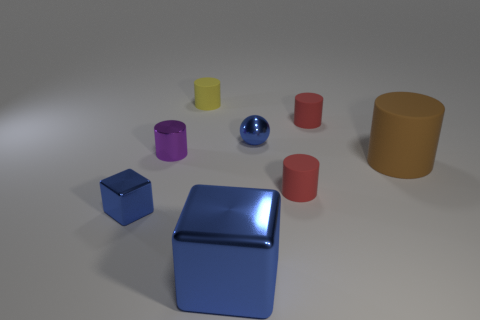Subtract 2 cylinders. How many cylinders are left? 3 Subtract all cyan cylinders. Subtract all purple cubes. How many cylinders are left? 5 Add 1 brown things. How many objects exist? 9 Subtract all cylinders. How many objects are left? 3 Add 3 metallic objects. How many metallic objects are left? 7 Add 2 tiny spheres. How many tiny spheres exist? 3 Subtract 0 green spheres. How many objects are left? 8 Subtract all small red matte objects. Subtract all big cylinders. How many objects are left? 5 